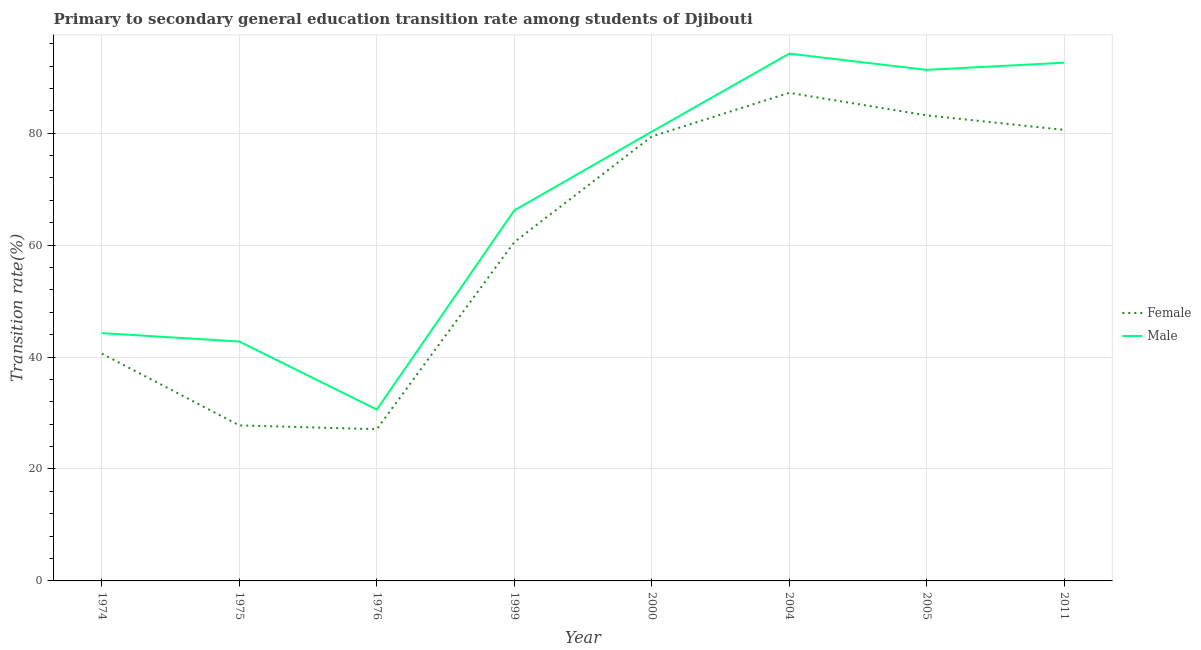Does the line corresponding to transition rate among female students intersect with the line corresponding to transition rate among male students?
Offer a terse response. No. What is the transition rate among female students in 1974?
Make the answer very short. 40.61. Across all years, what is the maximum transition rate among female students?
Offer a very short reply. 87.22. Across all years, what is the minimum transition rate among female students?
Give a very brief answer. 27.11. In which year was the transition rate among male students minimum?
Your answer should be very brief. 1976. What is the total transition rate among male students in the graph?
Your answer should be compact. 542.28. What is the difference between the transition rate among female students in 1974 and that in 1975?
Offer a terse response. 12.82. What is the difference between the transition rate among female students in 2005 and the transition rate among male students in 1976?
Make the answer very short. 52.57. What is the average transition rate among male students per year?
Your response must be concise. 67.79. In the year 2011, what is the difference between the transition rate among male students and transition rate among female students?
Keep it short and to the point. 12.01. What is the ratio of the transition rate among male students in 2004 to that in 2005?
Provide a succinct answer. 1.03. Is the transition rate among female students in 1976 less than that in 2011?
Provide a succinct answer. Yes. What is the difference between the highest and the second highest transition rate among male students?
Make the answer very short. 1.62. What is the difference between the highest and the lowest transition rate among male students?
Keep it short and to the point. 63.6. Does the transition rate among female students monotonically increase over the years?
Your answer should be very brief. No. Is the transition rate among female students strictly greater than the transition rate among male students over the years?
Provide a short and direct response. No. Is the transition rate among male students strictly less than the transition rate among female students over the years?
Provide a succinct answer. No. How many lines are there?
Keep it short and to the point. 2. What is the difference between two consecutive major ticks on the Y-axis?
Your response must be concise. 20. Does the graph contain any zero values?
Provide a succinct answer. No. Where does the legend appear in the graph?
Keep it short and to the point. Center right. How are the legend labels stacked?
Provide a short and direct response. Vertical. What is the title of the graph?
Make the answer very short. Primary to secondary general education transition rate among students of Djibouti. Does "Attending school" appear as one of the legend labels in the graph?
Provide a short and direct response. No. What is the label or title of the Y-axis?
Keep it short and to the point. Transition rate(%). What is the Transition rate(%) of Female in 1974?
Ensure brevity in your answer.  40.61. What is the Transition rate(%) in Male in 1974?
Keep it short and to the point. 44.28. What is the Transition rate(%) of Female in 1975?
Give a very brief answer. 27.79. What is the Transition rate(%) of Male in 1975?
Make the answer very short. 42.78. What is the Transition rate(%) of Female in 1976?
Your answer should be compact. 27.11. What is the Transition rate(%) of Male in 1976?
Your response must be concise. 30.61. What is the Transition rate(%) of Female in 1999?
Keep it short and to the point. 60.55. What is the Transition rate(%) in Male in 1999?
Provide a short and direct response. 66.21. What is the Transition rate(%) of Female in 2000?
Ensure brevity in your answer.  79.42. What is the Transition rate(%) in Male in 2000?
Your answer should be compact. 80.27. What is the Transition rate(%) in Female in 2004?
Offer a terse response. 87.22. What is the Transition rate(%) in Male in 2004?
Your answer should be very brief. 94.22. What is the Transition rate(%) in Female in 2005?
Provide a succinct answer. 83.19. What is the Transition rate(%) in Male in 2005?
Provide a succinct answer. 91.32. What is the Transition rate(%) of Female in 2011?
Offer a terse response. 80.59. What is the Transition rate(%) of Male in 2011?
Give a very brief answer. 92.6. Across all years, what is the maximum Transition rate(%) of Female?
Provide a short and direct response. 87.22. Across all years, what is the maximum Transition rate(%) of Male?
Give a very brief answer. 94.22. Across all years, what is the minimum Transition rate(%) of Female?
Make the answer very short. 27.11. Across all years, what is the minimum Transition rate(%) of Male?
Your answer should be very brief. 30.61. What is the total Transition rate(%) in Female in the graph?
Provide a short and direct response. 486.48. What is the total Transition rate(%) in Male in the graph?
Offer a very short reply. 542.28. What is the difference between the Transition rate(%) in Female in 1974 and that in 1975?
Your response must be concise. 12.82. What is the difference between the Transition rate(%) of Male in 1974 and that in 1975?
Provide a succinct answer. 1.5. What is the difference between the Transition rate(%) in Female in 1974 and that in 1976?
Make the answer very short. 13.5. What is the difference between the Transition rate(%) in Male in 1974 and that in 1976?
Provide a succinct answer. 13.66. What is the difference between the Transition rate(%) in Female in 1974 and that in 1999?
Make the answer very short. -19.93. What is the difference between the Transition rate(%) in Male in 1974 and that in 1999?
Provide a short and direct response. -21.93. What is the difference between the Transition rate(%) of Female in 1974 and that in 2000?
Your answer should be compact. -38.8. What is the difference between the Transition rate(%) in Male in 1974 and that in 2000?
Make the answer very short. -35.99. What is the difference between the Transition rate(%) in Female in 1974 and that in 2004?
Keep it short and to the point. -46.6. What is the difference between the Transition rate(%) in Male in 1974 and that in 2004?
Your answer should be compact. -49.94. What is the difference between the Transition rate(%) in Female in 1974 and that in 2005?
Provide a short and direct response. -42.57. What is the difference between the Transition rate(%) of Male in 1974 and that in 2005?
Provide a succinct answer. -47.04. What is the difference between the Transition rate(%) in Female in 1974 and that in 2011?
Your answer should be compact. -39.98. What is the difference between the Transition rate(%) in Male in 1974 and that in 2011?
Your answer should be compact. -48.32. What is the difference between the Transition rate(%) of Female in 1975 and that in 1976?
Provide a short and direct response. 0.68. What is the difference between the Transition rate(%) in Male in 1975 and that in 1976?
Give a very brief answer. 12.16. What is the difference between the Transition rate(%) of Female in 1975 and that in 1999?
Provide a short and direct response. -32.75. What is the difference between the Transition rate(%) in Male in 1975 and that in 1999?
Offer a terse response. -23.43. What is the difference between the Transition rate(%) of Female in 1975 and that in 2000?
Provide a succinct answer. -51.63. What is the difference between the Transition rate(%) in Male in 1975 and that in 2000?
Your response must be concise. -37.5. What is the difference between the Transition rate(%) in Female in 1975 and that in 2004?
Provide a short and direct response. -59.42. What is the difference between the Transition rate(%) of Male in 1975 and that in 2004?
Offer a terse response. -51.44. What is the difference between the Transition rate(%) in Female in 1975 and that in 2005?
Keep it short and to the point. -55.4. What is the difference between the Transition rate(%) of Male in 1975 and that in 2005?
Provide a short and direct response. -48.54. What is the difference between the Transition rate(%) of Female in 1975 and that in 2011?
Ensure brevity in your answer.  -52.8. What is the difference between the Transition rate(%) of Male in 1975 and that in 2011?
Provide a succinct answer. -49.82. What is the difference between the Transition rate(%) of Female in 1976 and that in 1999?
Your answer should be compact. -33.43. What is the difference between the Transition rate(%) in Male in 1976 and that in 1999?
Ensure brevity in your answer.  -35.59. What is the difference between the Transition rate(%) of Female in 1976 and that in 2000?
Keep it short and to the point. -52.3. What is the difference between the Transition rate(%) in Male in 1976 and that in 2000?
Your answer should be very brief. -49.66. What is the difference between the Transition rate(%) in Female in 1976 and that in 2004?
Offer a very short reply. -60.1. What is the difference between the Transition rate(%) in Male in 1976 and that in 2004?
Your answer should be very brief. -63.6. What is the difference between the Transition rate(%) in Female in 1976 and that in 2005?
Ensure brevity in your answer.  -56.07. What is the difference between the Transition rate(%) in Male in 1976 and that in 2005?
Your response must be concise. -60.7. What is the difference between the Transition rate(%) of Female in 1976 and that in 2011?
Provide a short and direct response. -53.48. What is the difference between the Transition rate(%) in Male in 1976 and that in 2011?
Provide a succinct answer. -61.98. What is the difference between the Transition rate(%) in Female in 1999 and that in 2000?
Offer a terse response. -18.87. What is the difference between the Transition rate(%) of Male in 1999 and that in 2000?
Offer a terse response. -14.07. What is the difference between the Transition rate(%) of Female in 1999 and that in 2004?
Ensure brevity in your answer.  -26.67. What is the difference between the Transition rate(%) of Male in 1999 and that in 2004?
Your answer should be very brief. -28.01. What is the difference between the Transition rate(%) of Female in 1999 and that in 2005?
Give a very brief answer. -22.64. What is the difference between the Transition rate(%) of Male in 1999 and that in 2005?
Ensure brevity in your answer.  -25.11. What is the difference between the Transition rate(%) in Female in 1999 and that in 2011?
Make the answer very short. -20.04. What is the difference between the Transition rate(%) in Male in 1999 and that in 2011?
Your answer should be very brief. -26.39. What is the difference between the Transition rate(%) in Female in 2000 and that in 2004?
Give a very brief answer. -7.8. What is the difference between the Transition rate(%) of Male in 2000 and that in 2004?
Your response must be concise. -13.94. What is the difference between the Transition rate(%) of Female in 2000 and that in 2005?
Provide a short and direct response. -3.77. What is the difference between the Transition rate(%) of Male in 2000 and that in 2005?
Offer a terse response. -11.04. What is the difference between the Transition rate(%) of Female in 2000 and that in 2011?
Make the answer very short. -1.17. What is the difference between the Transition rate(%) of Male in 2000 and that in 2011?
Your response must be concise. -12.32. What is the difference between the Transition rate(%) of Female in 2004 and that in 2005?
Ensure brevity in your answer.  4.03. What is the difference between the Transition rate(%) of Male in 2004 and that in 2005?
Your response must be concise. 2.9. What is the difference between the Transition rate(%) in Female in 2004 and that in 2011?
Offer a very short reply. 6.63. What is the difference between the Transition rate(%) in Male in 2004 and that in 2011?
Provide a succinct answer. 1.62. What is the difference between the Transition rate(%) in Female in 2005 and that in 2011?
Offer a very short reply. 2.6. What is the difference between the Transition rate(%) in Male in 2005 and that in 2011?
Your response must be concise. -1.28. What is the difference between the Transition rate(%) of Female in 1974 and the Transition rate(%) of Male in 1975?
Keep it short and to the point. -2.16. What is the difference between the Transition rate(%) of Female in 1974 and the Transition rate(%) of Male in 1976?
Make the answer very short. 10. What is the difference between the Transition rate(%) of Female in 1974 and the Transition rate(%) of Male in 1999?
Provide a succinct answer. -25.59. What is the difference between the Transition rate(%) in Female in 1974 and the Transition rate(%) in Male in 2000?
Offer a very short reply. -39.66. What is the difference between the Transition rate(%) in Female in 1974 and the Transition rate(%) in Male in 2004?
Make the answer very short. -53.6. What is the difference between the Transition rate(%) in Female in 1974 and the Transition rate(%) in Male in 2005?
Make the answer very short. -50.7. What is the difference between the Transition rate(%) in Female in 1974 and the Transition rate(%) in Male in 2011?
Keep it short and to the point. -51.98. What is the difference between the Transition rate(%) in Female in 1975 and the Transition rate(%) in Male in 1976?
Ensure brevity in your answer.  -2.82. What is the difference between the Transition rate(%) of Female in 1975 and the Transition rate(%) of Male in 1999?
Your response must be concise. -38.41. What is the difference between the Transition rate(%) of Female in 1975 and the Transition rate(%) of Male in 2000?
Offer a very short reply. -52.48. What is the difference between the Transition rate(%) in Female in 1975 and the Transition rate(%) in Male in 2004?
Provide a short and direct response. -66.42. What is the difference between the Transition rate(%) of Female in 1975 and the Transition rate(%) of Male in 2005?
Offer a very short reply. -63.52. What is the difference between the Transition rate(%) in Female in 1975 and the Transition rate(%) in Male in 2011?
Provide a succinct answer. -64.81. What is the difference between the Transition rate(%) of Female in 1976 and the Transition rate(%) of Male in 1999?
Keep it short and to the point. -39.09. What is the difference between the Transition rate(%) of Female in 1976 and the Transition rate(%) of Male in 2000?
Provide a short and direct response. -53.16. What is the difference between the Transition rate(%) in Female in 1976 and the Transition rate(%) in Male in 2004?
Keep it short and to the point. -67.1. What is the difference between the Transition rate(%) in Female in 1976 and the Transition rate(%) in Male in 2005?
Your answer should be very brief. -64.2. What is the difference between the Transition rate(%) of Female in 1976 and the Transition rate(%) of Male in 2011?
Your answer should be compact. -65.48. What is the difference between the Transition rate(%) in Female in 1999 and the Transition rate(%) in Male in 2000?
Make the answer very short. -19.73. What is the difference between the Transition rate(%) in Female in 1999 and the Transition rate(%) in Male in 2004?
Keep it short and to the point. -33.67. What is the difference between the Transition rate(%) of Female in 1999 and the Transition rate(%) of Male in 2005?
Offer a terse response. -30.77. What is the difference between the Transition rate(%) of Female in 1999 and the Transition rate(%) of Male in 2011?
Your answer should be very brief. -32.05. What is the difference between the Transition rate(%) of Female in 2000 and the Transition rate(%) of Male in 2004?
Provide a short and direct response. -14.8. What is the difference between the Transition rate(%) in Female in 2000 and the Transition rate(%) in Male in 2005?
Your response must be concise. -11.9. What is the difference between the Transition rate(%) of Female in 2000 and the Transition rate(%) of Male in 2011?
Ensure brevity in your answer.  -13.18. What is the difference between the Transition rate(%) of Female in 2004 and the Transition rate(%) of Male in 2005?
Provide a succinct answer. -4.1. What is the difference between the Transition rate(%) of Female in 2004 and the Transition rate(%) of Male in 2011?
Provide a short and direct response. -5.38. What is the difference between the Transition rate(%) of Female in 2005 and the Transition rate(%) of Male in 2011?
Your answer should be very brief. -9.41. What is the average Transition rate(%) of Female per year?
Your answer should be very brief. 60.81. What is the average Transition rate(%) of Male per year?
Offer a terse response. 67.79. In the year 1974, what is the difference between the Transition rate(%) of Female and Transition rate(%) of Male?
Ensure brevity in your answer.  -3.67. In the year 1975, what is the difference between the Transition rate(%) in Female and Transition rate(%) in Male?
Provide a short and direct response. -14.98. In the year 1976, what is the difference between the Transition rate(%) in Female and Transition rate(%) in Male?
Give a very brief answer. -3.5. In the year 1999, what is the difference between the Transition rate(%) in Female and Transition rate(%) in Male?
Give a very brief answer. -5.66. In the year 2000, what is the difference between the Transition rate(%) in Female and Transition rate(%) in Male?
Make the answer very short. -0.85. In the year 2004, what is the difference between the Transition rate(%) in Female and Transition rate(%) in Male?
Your answer should be compact. -7. In the year 2005, what is the difference between the Transition rate(%) of Female and Transition rate(%) of Male?
Your response must be concise. -8.13. In the year 2011, what is the difference between the Transition rate(%) in Female and Transition rate(%) in Male?
Offer a terse response. -12.01. What is the ratio of the Transition rate(%) in Female in 1974 to that in 1975?
Your answer should be very brief. 1.46. What is the ratio of the Transition rate(%) of Male in 1974 to that in 1975?
Your answer should be compact. 1.04. What is the ratio of the Transition rate(%) in Female in 1974 to that in 1976?
Make the answer very short. 1.5. What is the ratio of the Transition rate(%) of Male in 1974 to that in 1976?
Keep it short and to the point. 1.45. What is the ratio of the Transition rate(%) of Female in 1974 to that in 1999?
Your answer should be very brief. 0.67. What is the ratio of the Transition rate(%) in Male in 1974 to that in 1999?
Your answer should be very brief. 0.67. What is the ratio of the Transition rate(%) in Female in 1974 to that in 2000?
Your answer should be compact. 0.51. What is the ratio of the Transition rate(%) of Male in 1974 to that in 2000?
Ensure brevity in your answer.  0.55. What is the ratio of the Transition rate(%) of Female in 1974 to that in 2004?
Your answer should be very brief. 0.47. What is the ratio of the Transition rate(%) in Male in 1974 to that in 2004?
Your response must be concise. 0.47. What is the ratio of the Transition rate(%) in Female in 1974 to that in 2005?
Make the answer very short. 0.49. What is the ratio of the Transition rate(%) of Male in 1974 to that in 2005?
Keep it short and to the point. 0.48. What is the ratio of the Transition rate(%) of Female in 1974 to that in 2011?
Offer a very short reply. 0.5. What is the ratio of the Transition rate(%) in Male in 1974 to that in 2011?
Provide a succinct answer. 0.48. What is the ratio of the Transition rate(%) in Female in 1975 to that in 1976?
Give a very brief answer. 1.03. What is the ratio of the Transition rate(%) in Male in 1975 to that in 1976?
Make the answer very short. 1.4. What is the ratio of the Transition rate(%) in Female in 1975 to that in 1999?
Keep it short and to the point. 0.46. What is the ratio of the Transition rate(%) in Male in 1975 to that in 1999?
Offer a very short reply. 0.65. What is the ratio of the Transition rate(%) of Male in 1975 to that in 2000?
Your answer should be compact. 0.53. What is the ratio of the Transition rate(%) of Female in 1975 to that in 2004?
Your response must be concise. 0.32. What is the ratio of the Transition rate(%) in Male in 1975 to that in 2004?
Keep it short and to the point. 0.45. What is the ratio of the Transition rate(%) in Female in 1975 to that in 2005?
Your response must be concise. 0.33. What is the ratio of the Transition rate(%) of Male in 1975 to that in 2005?
Provide a succinct answer. 0.47. What is the ratio of the Transition rate(%) in Female in 1975 to that in 2011?
Offer a terse response. 0.34. What is the ratio of the Transition rate(%) in Male in 1975 to that in 2011?
Provide a short and direct response. 0.46. What is the ratio of the Transition rate(%) of Female in 1976 to that in 1999?
Offer a very short reply. 0.45. What is the ratio of the Transition rate(%) in Male in 1976 to that in 1999?
Ensure brevity in your answer.  0.46. What is the ratio of the Transition rate(%) of Female in 1976 to that in 2000?
Your answer should be compact. 0.34. What is the ratio of the Transition rate(%) in Male in 1976 to that in 2000?
Ensure brevity in your answer.  0.38. What is the ratio of the Transition rate(%) in Female in 1976 to that in 2004?
Offer a very short reply. 0.31. What is the ratio of the Transition rate(%) in Male in 1976 to that in 2004?
Provide a short and direct response. 0.32. What is the ratio of the Transition rate(%) of Female in 1976 to that in 2005?
Provide a short and direct response. 0.33. What is the ratio of the Transition rate(%) of Male in 1976 to that in 2005?
Your answer should be very brief. 0.34. What is the ratio of the Transition rate(%) of Female in 1976 to that in 2011?
Your answer should be very brief. 0.34. What is the ratio of the Transition rate(%) in Male in 1976 to that in 2011?
Your answer should be very brief. 0.33. What is the ratio of the Transition rate(%) in Female in 1999 to that in 2000?
Provide a succinct answer. 0.76. What is the ratio of the Transition rate(%) in Male in 1999 to that in 2000?
Provide a short and direct response. 0.82. What is the ratio of the Transition rate(%) of Female in 1999 to that in 2004?
Give a very brief answer. 0.69. What is the ratio of the Transition rate(%) in Male in 1999 to that in 2004?
Offer a terse response. 0.7. What is the ratio of the Transition rate(%) in Female in 1999 to that in 2005?
Provide a succinct answer. 0.73. What is the ratio of the Transition rate(%) of Male in 1999 to that in 2005?
Ensure brevity in your answer.  0.72. What is the ratio of the Transition rate(%) of Female in 1999 to that in 2011?
Offer a very short reply. 0.75. What is the ratio of the Transition rate(%) of Male in 1999 to that in 2011?
Your answer should be compact. 0.71. What is the ratio of the Transition rate(%) of Female in 2000 to that in 2004?
Offer a very short reply. 0.91. What is the ratio of the Transition rate(%) in Male in 2000 to that in 2004?
Your answer should be compact. 0.85. What is the ratio of the Transition rate(%) of Female in 2000 to that in 2005?
Provide a short and direct response. 0.95. What is the ratio of the Transition rate(%) in Male in 2000 to that in 2005?
Provide a short and direct response. 0.88. What is the ratio of the Transition rate(%) in Female in 2000 to that in 2011?
Your answer should be very brief. 0.99. What is the ratio of the Transition rate(%) of Male in 2000 to that in 2011?
Your response must be concise. 0.87. What is the ratio of the Transition rate(%) in Female in 2004 to that in 2005?
Provide a succinct answer. 1.05. What is the ratio of the Transition rate(%) in Male in 2004 to that in 2005?
Offer a terse response. 1.03. What is the ratio of the Transition rate(%) of Female in 2004 to that in 2011?
Provide a short and direct response. 1.08. What is the ratio of the Transition rate(%) in Male in 2004 to that in 2011?
Offer a terse response. 1.02. What is the ratio of the Transition rate(%) in Female in 2005 to that in 2011?
Your response must be concise. 1.03. What is the ratio of the Transition rate(%) in Male in 2005 to that in 2011?
Your response must be concise. 0.99. What is the difference between the highest and the second highest Transition rate(%) in Female?
Make the answer very short. 4.03. What is the difference between the highest and the second highest Transition rate(%) in Male?
Offer a very short reply. 1.62. What is the difference between the highest and the lowest Transition rate(%) of Female?
Your response must be concise. 60.1. What is the difference between the highest and the lowest Transition rate(%) in Male?
Keep it short and to the point. 63.6. 